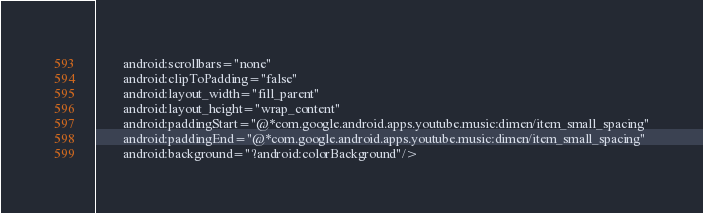Convert code to text. <code><loc_0><loc_0><loc_500><loc_500><_XML_>        android:scrollbars="none"
        android:clipToPadding="false"
        android:layout_width="fill_parent"
        android:layout_height="wrap_content"
        android:paddingStart="@*com.google.android.apps.youtube.music:dimen/item_small_spacing"
        android:paddingEnd="@*com.google.android.apps.youtube.music:dimen/item_small_spacing"
        android:background="?android:colorBackground"/>
</code> 